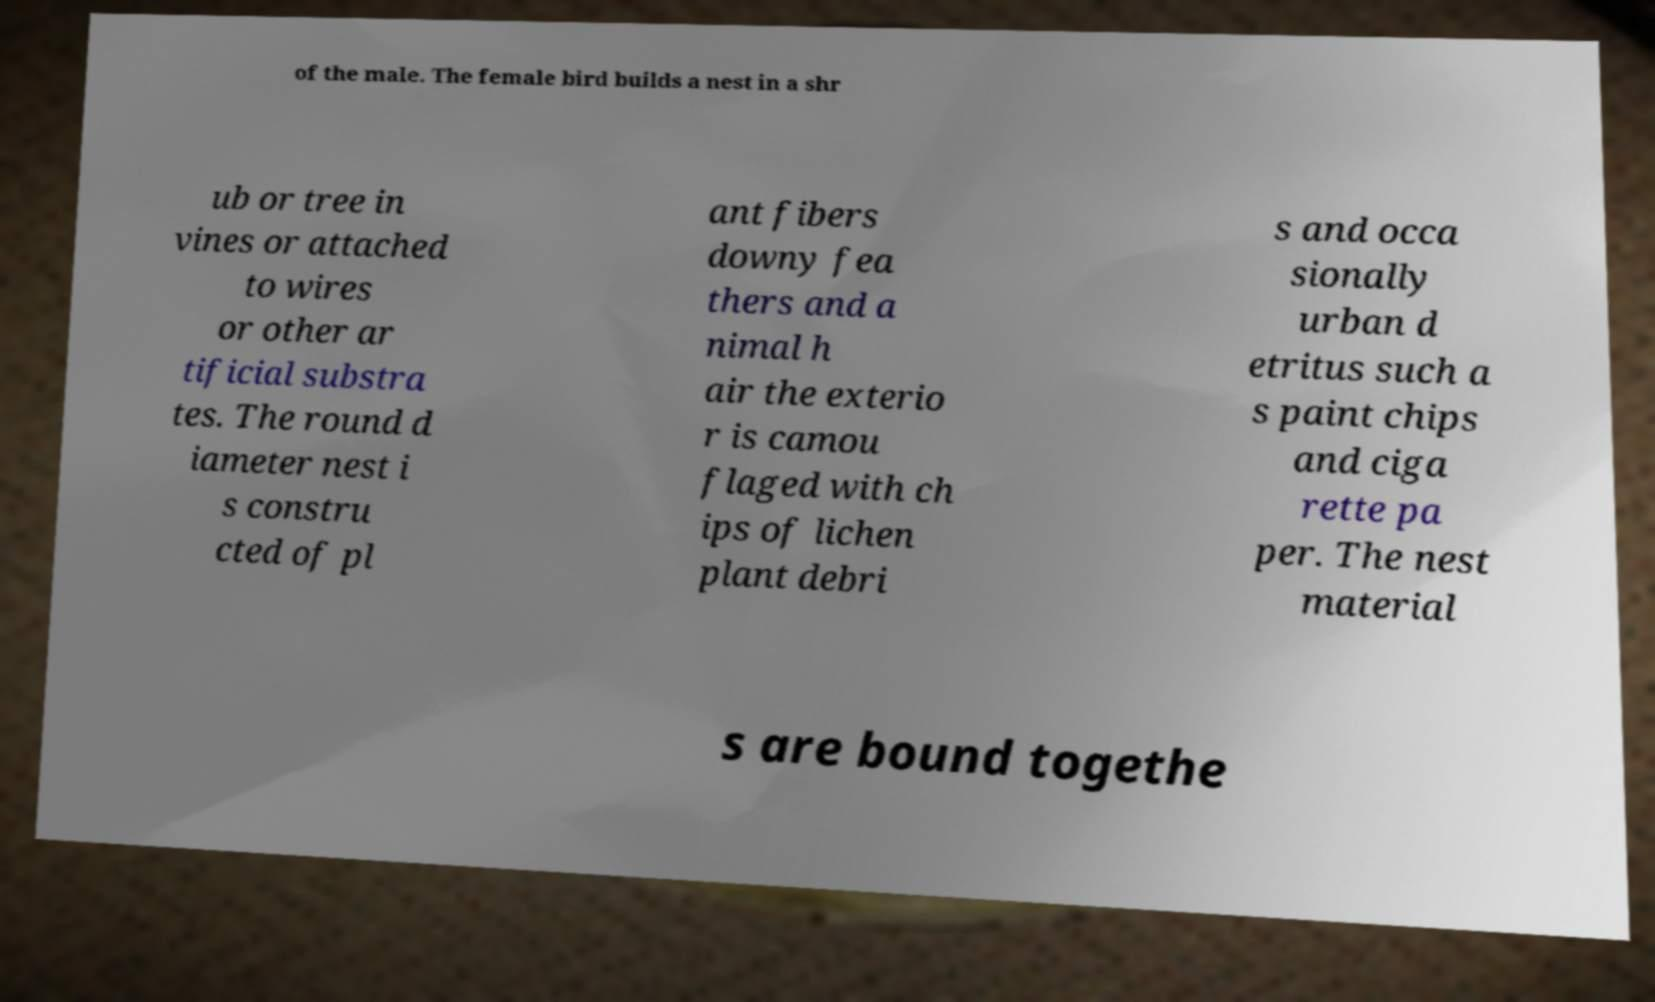Can you accurately transcribe the text from the provided image for me? of the male. The female bird builds a nest in a shr ub or tree in vines or attached to wires or other ar tificial substra tes. The round d iameter nest i s constru cted of pl ant fibers downy fea thers and a nimal h air the exterio r is camou flaged with ch ips of lichen plant debri s and occa sionally urban d etritus such a s paint chips and ciga rette pa per. The nest material s are bound togethe 